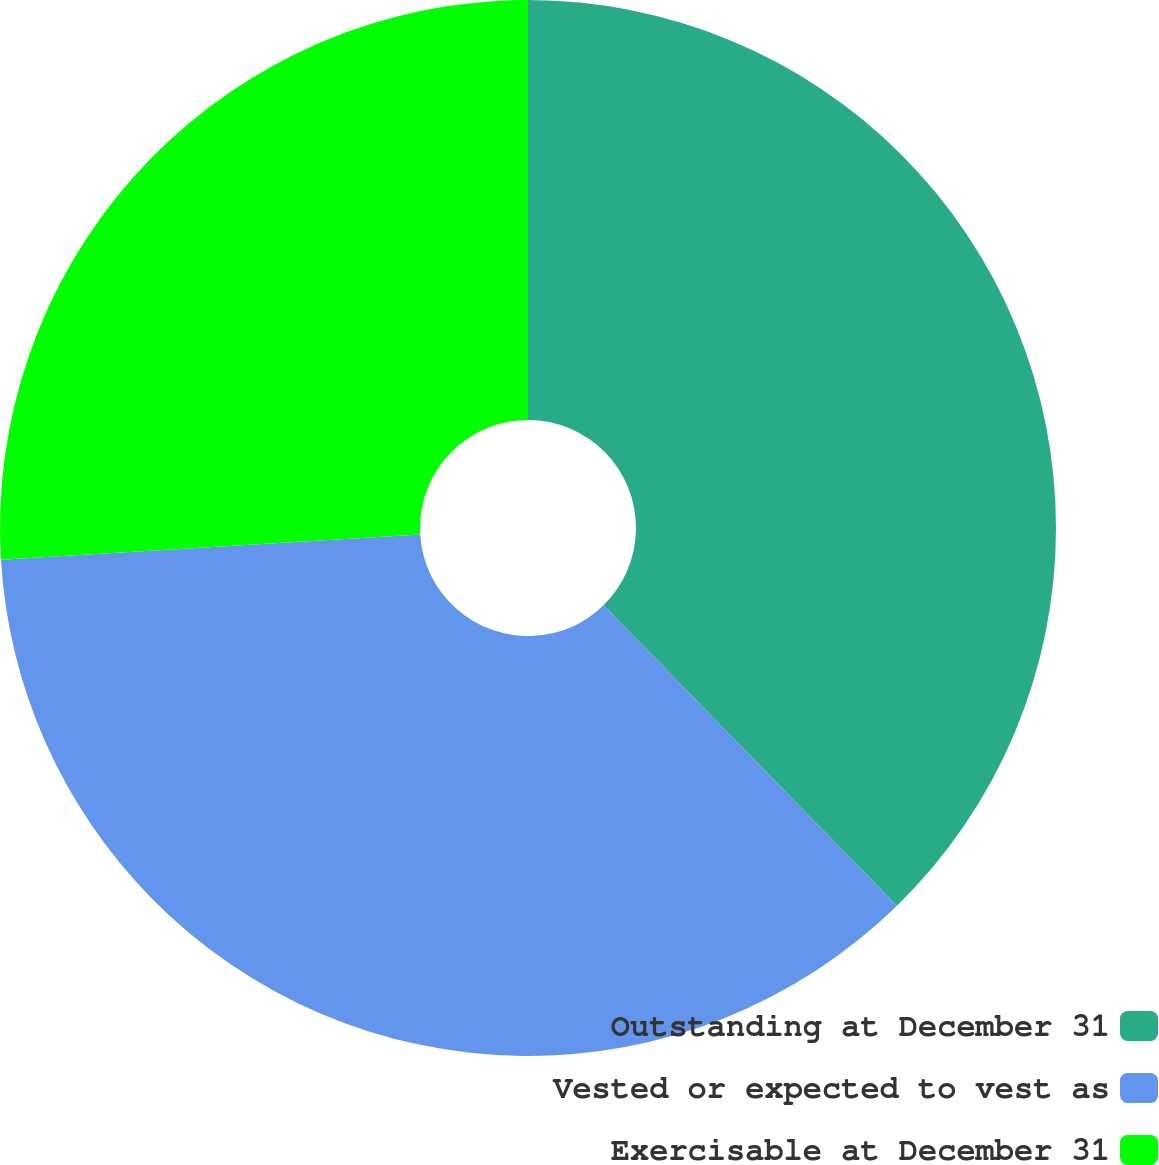Convert chart. <chart><loc_0><loc_0><loc_500><loc_500><pie_chart><fcel>Outstanding at December 31<fcel>Vested or expected to vest as<fcel>Exercisable at December 31<nl><fcel>37.69%<fcel>36.36%<fcel>25.96%<nl></chart> 